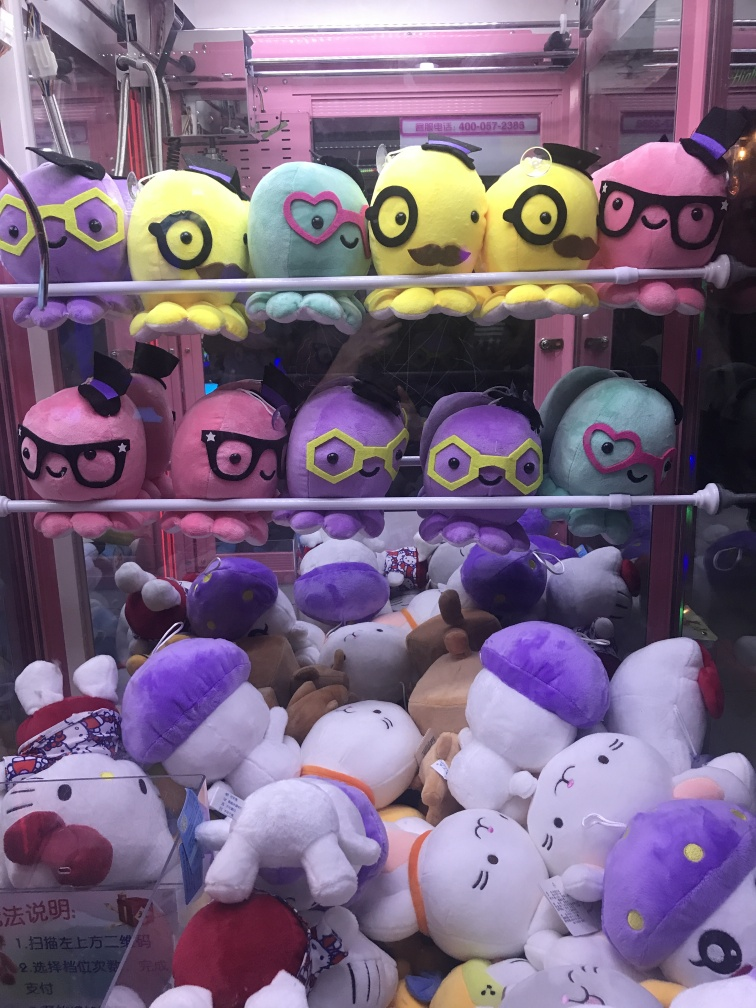What are the texture details in the background? The background of the image showcases a variety of plush toys inside a claw machine, with different textures noticeable on the toys. The upper shelf is lined with plush birds that have a smooth, velvety fabric in vibrant yellows, purples, and greens, some wearing glasses or hats. The bottom is filled with a mix of animals including bears and rabbits, appearing soft and fluffy with some dressed in costumes which add an element of playful texture contrast, such as shiny satin-like pirate hats and felt accessories. 